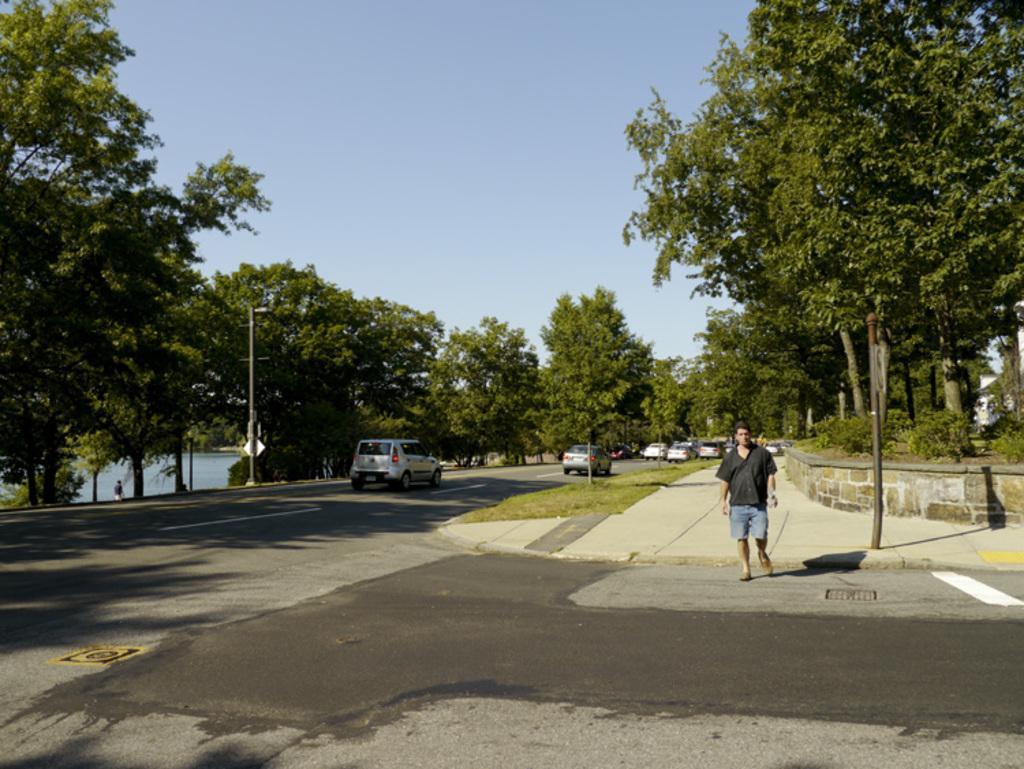Could you give a brief overview of what you see in this image? In this image we can see a man standing on the road, vehicles, trees, plants, poles and in the background we can see the sky. 